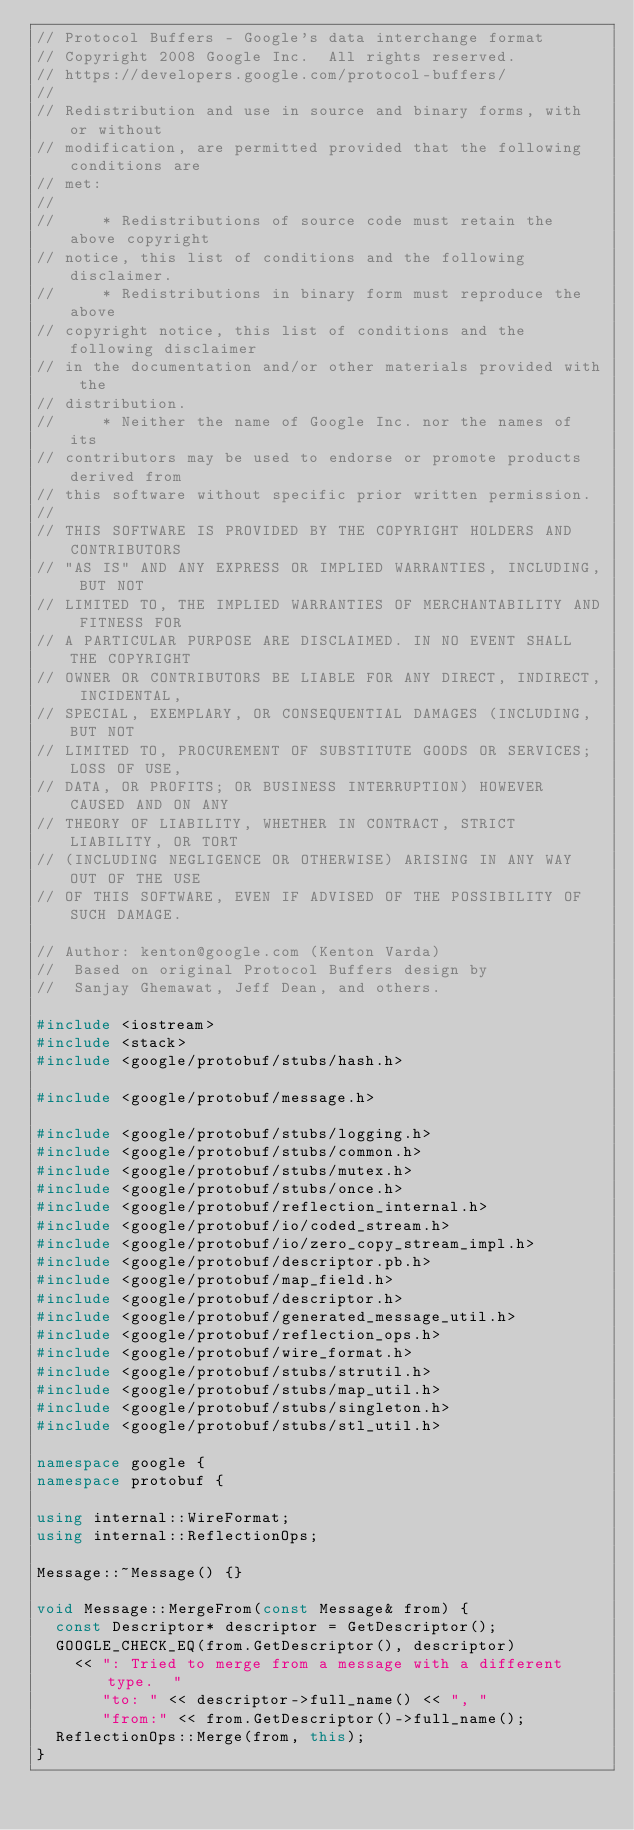Convert code to text. <code><loc_0><loc_0><loc_500><loc_500><_C++_>// Protocol Buffers - Google's data interchange format
// Copyright 2008 Google Inc.  All rights reserved.
// https://developers.google.com/protocol-buffers/
//
// Redistribution and use in source and binary forms, with or without
// modification, are permitted provided that the following conditions are
// met:
//
//     * Redistributions of source code must retain the above copyright
// notice, this list of conditions and the following disclaimer.
//     * Redistributions in binary form must reproduce the above
// copyright notice, this list of conditions and the following disclaimer
// in the documentation and/or other materials provided with the
// distribution.
//     * Neither the name of Google Inc. nor the names of its
// contributors may be used to endorse or promote products derived from
// this software without specific prior written permission.
//
// THIS SOFTWARE IS PROVIDED BY THE COPYRIGHT HOLDERS AND CONTRIBUTORS
// "AS IS" AND ANY EXPRESS OR IMPLIED WARRANTIES, INCLUDING, BUT NOT
// LIMITED TO, THE IMPLIED WARRANTIES OF MERCHANTABILITY AND FITNESS FOR
// A PARTICULAR PURPOSE ARE DISCLAIMED. IN NO EVENT SHALL THE COPYRIGHT
// OWNER OR CONTRIBUTORS BE LIABLE FOR ANY DIRECT, INDIRECT, INCIDENTAL,
// SPECIAL, EXEMPLARY, OR CONSEQUENTIAL DAMAGES (INCLUDING, BUT NOT
// LIMITED TO, PROCUREMENT OF SUBSTITUTE GOODS OR SERVICES; LOSS OF USE,
// DATA, OR PROFITS; OR BUSINESS INTERRUPTION) HOWEVER CAUSED AND ON ANY
// THEORY OF LIABILITY, WHETHER IN CONTRACT, STRICT LIABILITY, OR TORT
// (INCLUDING NEGLIGENCE OR OTHERWISE) ARISING IN ANY WAY OUT OF THE USE
// OF THIS SOFTWARE, EVEN IF ADVISED OF THE POSSIBILITY OF SUCH DAMAGE.

// Author: kenton@google.com (Kenton Varda)
//  Based on original Protocol Buffers design by
//  Sanjay Ghemawat, Jeff Dean, and others.

#include <iostream>
#include <stack>
#include <google/protobuf/stubs/hash.h>

#include <google/protobuf/message.h>

#include <google/protobuf/stubs/logging.h>
#include <google/protobuf/stubs/common.h>
#include <google/protobuf/stubs/mutex.h>
#include <google/protobuf/stubs/once.h>
#include <google/protobuf/reflection_internal.h>
#include <google/protobuf/io/coded_stream.h>
#include <google/protobuf/io/zero_copy_stream_impl.h>
#include <google/protobuf/descriptor.pb.h>
#include <google/protobuf/map_field.h>
#include <google/protobuf/descriptor.h>
#include <google/protobuf/generated_message_util.h>
#include <google/protobuf/reflection_ops.h>
#include <google/protobuf/wire_format.h>
#include <google/protobuf/stubs/strutil.h>
#include <google/protobuf/stubs/map_util.h>
#include <google/protobuf/stubs/singleton.h>
#include <google/protobuf/stubs/stl_util.h>

namespace google {
namespace protobuf {

using internal::WireFormat;
using internal::ReflectionOps;

Message::~Message() {}

void Message::MergeFrom(const Message& from) {
  const Descriptor* descriptor = GetDescriptor();
  GOOGLE_CHECK_EQ(from.GetDescriptor(), descriptor)
    << ": Tried to merge from a message with a different type.  "
       "to: " << descriptor->full_name() << ", "
       "from:" << from.GetDescriptor()->full_name();
  ReflectionOps::Merge(from, this);
}
</code> 